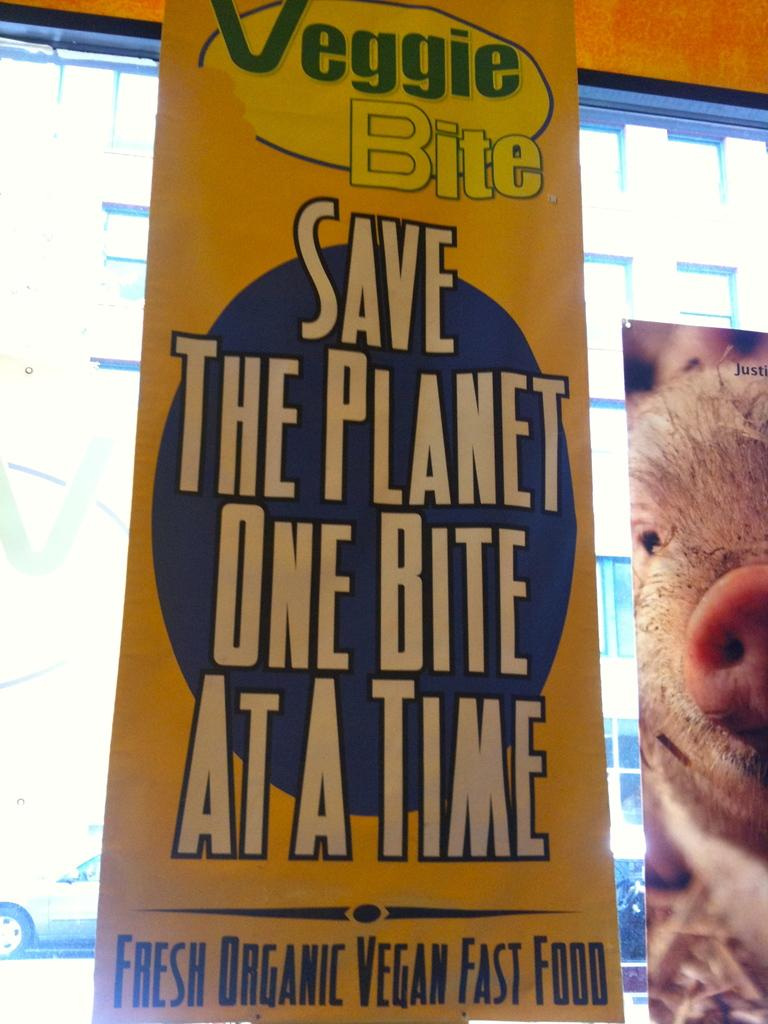What is hanging in the image? There is a banner in the image. What image is on the banner? There is a picture of a pig in the image. Where is the picture of a pig located in relation to the window? The picture of a pig is beside a window. What type of vehicle can be seen in the image? There is a car visible in the image. What type of popcorn is being served in the image? There is no popcorn present in the image. What color is the lipstick on the pig's lips in the image? There is no lipstick or pig's lips present in the image; it is a picture of a pig. 